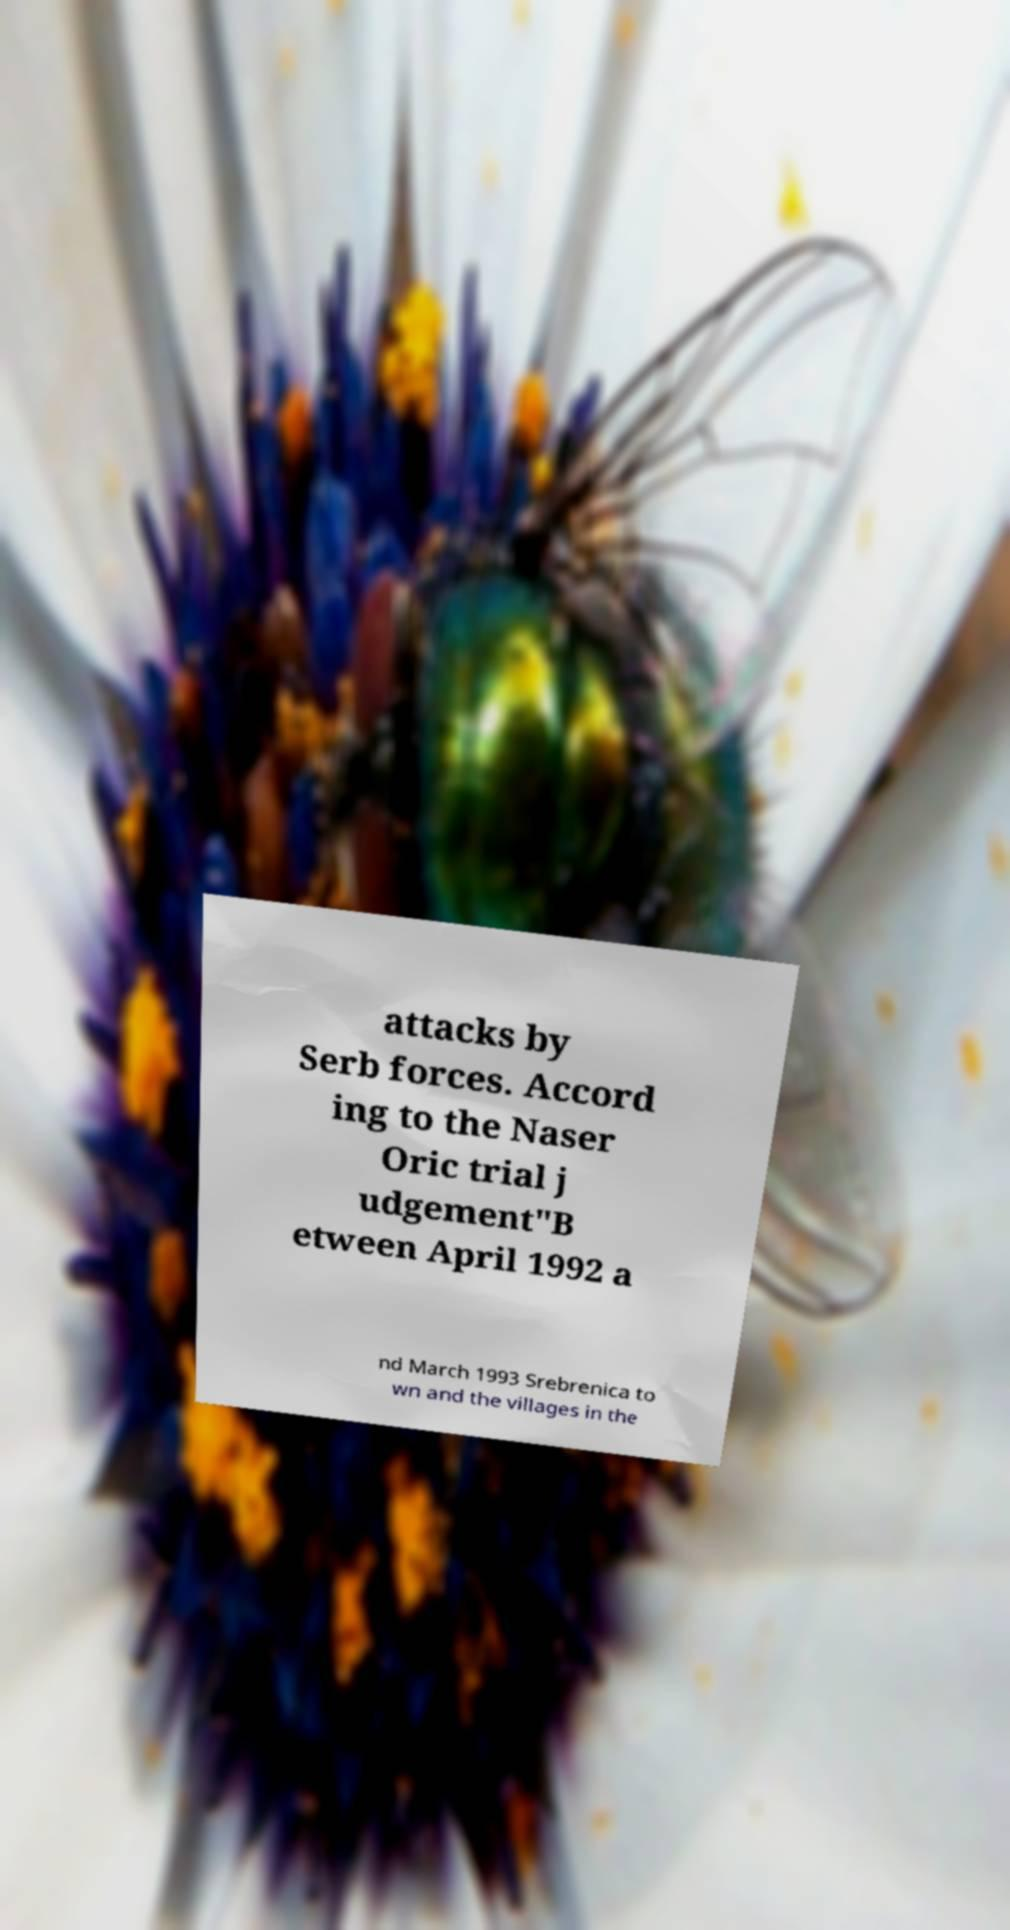What messages or text are displayed in this image? I need them in a readable, typed format. attacks by Serb forces. Accord ing to the Naser Oric trial j udgement"B etween April 1992 a nd March 1993 Srebrenica to wn and the villages in the 